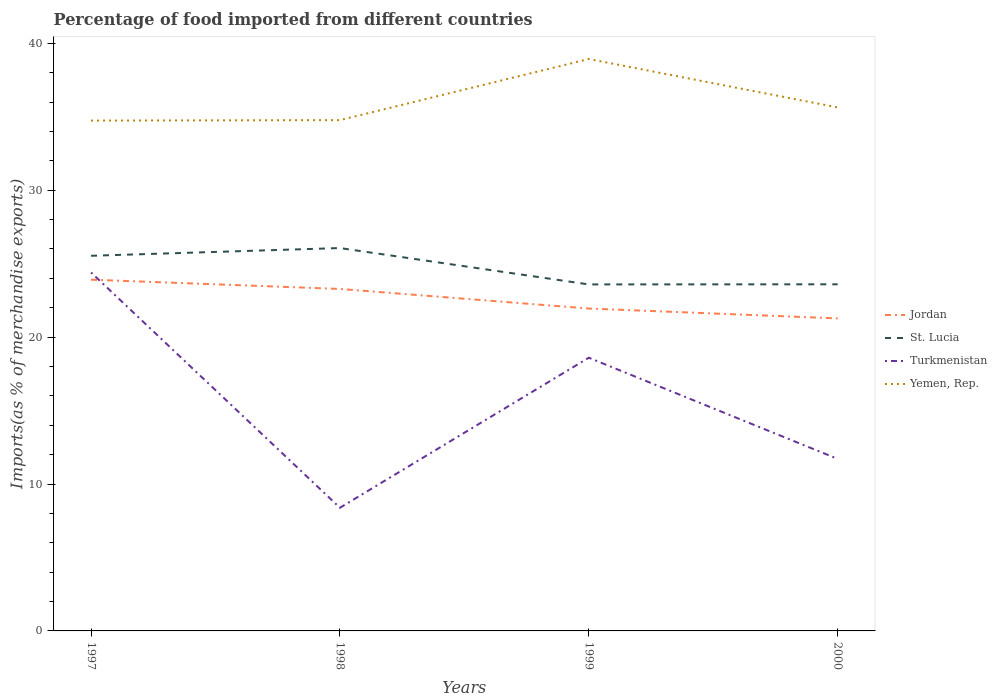Is the number of lines equal to the number of legend labels?
Your answer should be compact. Yes. Across all years, what is the maximum percentage of imports to different countries in Jordan?
Ensure brevity in your answer.  21.28. In which year was the percentage of imports to different countries in Turkmenistan maximum?
Offer a very short reply. 1998. What is the total percentage of imports to different countries in Turkmenistan in the graph?
Your answer should be compact. -10.21. What is the difference between the highest and the second highest percentage of imports to different countries in St. Lucia?
Offer a terse response. 2.48. What is the difference between the highest and the lowest percentage of imports to different countries in Yemen, Rep.?
Ensure brevity in your answer.  1. How many lines are there?
Ensure brevity in your answer.  4. Are the values on the major ticks of Y-axis written in scientific E-notation?
Keep it short and to the point. No. Where does the legend appear in the graph?
Offer a very short reply. Center right. How many legend labels are there?
Offer a terse response. 4. How are the legend labels stacked?
Make the answer very short. Vertical. What is the title of the graph?
Offer a very short reply. Percentage of food imported from different countries. What is the label or title of the X-axis?
Your answer should be very brief. Years. What is the label or title of the Y-axis?
Make the answer very short. Imports(as % of merchandise exports). What is the Imports(as % of merchandise exports) in Jordan in 1997?
Make the answer very short. 23.91. What is the Imports(as % of merchandise exports) of St. Lucia in 1997?
Keep it short and to the point. 25.54. What is the Imports(as % of merchandise exports) of Turkmenistan in 1997?
Your answer should be very brief. 24.4. What is the Imports(as % of merchandise exports) of Yemen, Rep. in 1997?
Your answer should be compact. 34.74. What is the Imports(as % of merchandise exports) of Jordan in 1998?
Provide a succinct answer. 23.28. What is the Imports(as % of merchandise exports) of St. Lucia in 1998?
Make the answer very short. 26.06. What is the Imports(as % of merchandise exports) of Turkmenistan in 1998?
Keep it short and to the point. 8.38. What is the Imports(as % of merchandise exports) of Yemen, Rep. in 1998?
Your answer should be very brief. 34.77. What is the Imports(as % of merchandise exports) of Jordan in 1999?
Your response must be concise. 21.95. What is the Imports(as % of merchandise exports) of St. Lucia in 1999?
Your answer should be very brief. 23.59. What is the Imports(as % of merchandise exports) of Turkmenistan in 1999?
Offer a terse response. 18.6. What is the Imports(as % of merchandise exports) in Yemen, Rep. in 1999?
Make the answer very short. 38.93. What is the Imports(as % of merchandise exports) in Jordan in 2000?
Your answer should be very brief. 21.28. What is the Imports(as % of merchandise exports) of St. Lucia in 2000?
Ensure brevity in your answer.  23.6. What is the Imports(as % of merchandise exports) of Turkmenistan in 2000?
Ensure brevity in your answer.  11.71. What is the Imports(as % of merchandise exports) in Yemen, Rep. in 2000?
Your answer should be compact. 35.64. Across all years, what is the maximum Imports(as % of merchandise exports) in Jordan?
Provide a short and direct response. 23.91. Across all years, what is the maximum Imports(as % of merchandise exports) of St. Lucia?
Offer a very short reply. 26.06. Across all years, what is the maximum Imports(as % of merchandise exports) of Turkmenistan?
Keep it short and to the point. 24.4. Across all years, what is the maximum Imports(as % of merchandise exports) in Yemen, Rep.?
Your answer should be compact. 38.93. Across all years, what is the minimum Imports(as % of merchandise exports) in Jordan?
Your answer should be very brief. 21.28. Across all years, what is the minimum Imports(as % of merchandise exports) of St. Lucia?
Offer a terse response. 23.59. Across all years, what is the minimum Imports(as % of merchandise exports) of Turkmenistan?
Your answer should be compact. 8.38. Across all years, what is the minimum Imports(as % of merchandise exports) of Yemen, Rep.?
Your answer should be very brief. 34.74. What is the total Imports(as % of merchandise exports) of Jordan in the graph?
Offer a very short reply. 90.41. What is the total Imports(as % of merchandise exports) of St. Lucia in the graph?
Give a very brief answer. 98.79. What is the total Imports(as % of merchandise exports) of Turkmenistan in the graph?
Keep it short and to the point. 63.1. What is the total Imports(as % of merchandise exports) in Yemen, Rep. in the graph?
Your response must be concise. 144.08. What is the difference between the Imports(as % of merchandise exports) in Jordan in 1997 and that in 1998?
Your answer should be very brief. 0.63. What is the difference between the Imports(as % of merchandise exports) in St. Lucia in 1997 and that in 1998?
Make the answer very short. -0.53. What is the difference between the Imports(as % of merchandise exports) in Turkmenistan in 1997 and that in 1998?
Make the answer very short. 16.02. What is the difference between the Imports(as % of merchandise exports) of Yemen, Rep. in 1997 and that in 1998?
Your answer should be compact. -0.03. What is the difference between the Imports(as % of merchandise exports) of Jordan in 1997 and that in 1999?
Make the answer very short. 1.96. What is the difference between the Imports(as % of merchandise exports) in St. Lucia in 1997 and that in 1999?
Give a very brief answer. 1.95. What is the difference between the Imports(as % of merchandise exports) in Turkmenistan in 1997 and that in 1999?
Your answer should be compact. 5.81. What is the difference between the Imports(as % of merchandise exports) in Yemen, Rep. in 1997 and that in 1999?
Provide a succinct answer. -4.19. What is the difference between the Imports(as % of merchandise exports) of Jordan in 1997 and that in 2000?
Offer a terse response. 2.64. What is the difference between the Imports(as % of merchandise exports) in St. Lucia in 1997 and that in 2000?
Give a very brief answer. 1.94. What is the difference between the Imports(as % of merchandise exports) of Turkmenistan in 1997 and that in 2000?
Ensure brevity in your answer.  12.69. What is the difference between the Imports(as % of merchandise exports) of Yemen, Rep. in 1997 and that in 2000?
Make the answer very short. -0.9. What is the difference between the Imports(as % of merchandise exports) in Jordan in 1998 and that in 1999?
Your answer should be compact. 1.33. What is the difference between the Imports(as % of merchandise exports) in St. Lucia in 1998 and that in 1999?
Offer a terse response. 2.48. What is the difference between the Imports(as % of merchandise exports) in Turkmenistan in 1998 and that in 1999?
Provide a succinct answer. -10.21. What is the difference between the Imports(as % of merchandise exports) in Yemen, Rep. in 1998 and that in 1999?
Make the answer very short. -4.16. What is the difference between the Imports(as % of merchandise exports) in Jordan in 1998 and that in 2000?
Your answer should be compact. 2. What is the difference between the Imports(as % of merchandise exports) of St. Lucia in 1998 and that in 2000?
Offer a terse response. 2.47. What is the difference between the Imports(as % of merchandise exports) in Turkmenistan in 1998 and that in 2000?
Your answer should be compact. -3.33. What is the difference between the Imports(as % of merchandise exports) in Yemen, Rep. in 1998 and that in 2000?
Provide a succinct answer. -0.86. What is the difference between the Imports(as % of merchandise exports) of Jordan in 1999 and that in 2000?
Offer a terse response. 0.67. What is the difference between the Imports(as % of merchandise exports) of St. Lucia in 1999 and that in 2000?
Your answer should be compact. -0.01. What is the difference between the Imports(as % of merchandise exports) in Turkmenistan in 1999 and that in 2000?
Give a very brief answer. 6.89. What is the difference between the Imports(as % of merchandise exports) in Yemen, Rep. in 1999 and that in 2000?
Make the answer very short. 3.3. What is the difference between the Imports(as % of merchandise exports) of Jordan in 1997 and the Imports(as % of merchandise exports) of St. Lucia in 1998?
Keep it short and to the point. -2.15. What is the difference between the Imports(as % of merchandise exports) of Jordan in 1997 and the Imports(as % of merchandise exports) of Turkmenistan in 1998?
Your answer should be compact. 15.53. What is the difference between the Imports(as % of merchandise exports) in Jordan in 1997 and the Imports(as % of merchandise exports) in Yemen, Rep. in 1998?
Make the answer very short. -10.86. What is the difference between the Imports(as % of merchandise exports) of St. Lucia in 1997 and the Imports(as % of merchandise exports) of Turkmenistan in 1998?
Keep it short and to the point. 17.15. What is the difference between the Imports(as % of merchandise exports) of St. Lucia in 1997 and the Imports(as % of merchandise exports) of Yemen, Rep. in 1998?
Keep it short and to the point. -9.23. What is the difference between the Imports(as % of merchandise exports) of Turkmenistan in 1997 and the Imports(as % of merchandise exports) of Yemen, Rep. in 1998?
Make the answer very short. -10.37. What is the difference between the Imports(as % of merchandise exports) of Jordan in 1997 and the Imports(as % of merchandise exports) of St. Lucia in 1999?
Ensure brevity in your answer.  0.32. What is the difference between the Imports(as % of merchandise exports) of Jordan in 1997 and the Imports(as % of merchandise exports) of Turkmenistan in 1999?
Offer a terse response. 5.31. What is the difference between the Imports(as % of merchandise exports) of Jordan in 1997 and the Imports(as % of merchandise exports) of Yemen, Rep. in 1999?
Provide a short and direct response. -15.02. What is the difference between the Imports(as % of merchandise exports) of St. Lucia in 1997 and the Imports(as % of merchandise exports) of Turkmenistan in 1999?
Provide a short and direct response. 6.94. What is the difference between the Imports(as % of merchandise exports) of St. Lucia in 1997 and the Imports(as % of merchandise exports) of Yemen, Rep. in 1999?
Your answer should be compact. -13.39. What is the difference between the Imports(as % of merchandise exports) of Turkmenistan in 1997 and the Imports(as % of merchandise exports) of Yemen, Rep. in 1999?
Provide a short and direct response. -14.53. What is the difference between the Imports(as % of merchandise exports) of Jordan in 1997 and the Imports(as % of merchandise exports) of St. Lucia in 2000?
Make the answer very short. 0.31. What is the difference between the Imports(as % of merchandise exports) of Jordan in 1997 and the Imports(as % of merchandise exports) of Turkmenistan in 2000?
Offer a very short reply. 12.2. What is the difference between the Imports(as % of merchandise exports) in Jordan in 1997 and the Imports(as % of merchandise exports) in Yemen, Rep. in 2000?
Offer a very short reply. -11.73. What is the difference between the Imports(as % of merchandise exports) in St. Lucia in 1997 and the Imports(as % of merchandise exports) in Turkmenistan in 2000?
Ensure brevity in your answer.  13.83. What is the difference between the Imports(as % of merchandise exports) of St. Lucia in 1997 and the Imports(as % of merchandise exports) of Yemen, Rep. in 2000?
Offer a terse response. -10.1. What is the difference between the Imports(as % of merchandise exports) of Turkmenistan in 1997 and the Imports(as % of merchandise exports) of Yemen, Rep. in 2000?
Provide a short and direct response. -11.23. What is the difference between the Imports(as % of merchandise exports) in Jordan in 1998 and the Imports(as % of merchandise exports) in St. Lucia in 1999?
Offer a terse response. -0.31. What is the difference between the Imports(as % of merchandise exports) in Jordan in 1998 and the Imports(as % of merchandise exports) in Turkmenistan in 1999?
Provide a short and direct response. 4.68. What is the difference between the Imports(as % of merchandise exports) in Jordan in 1998 and the Imports(as % of merchandise exports) in Yemen, Rep. in 1999?
Your answer should be compact. -15.65. What is the difference between the Imports(as % of merchandise exports) of St. Lucia in 1998 and the Imports(as % of merchandise exports) of Turkmenistan in 1999?
Make the answer very short. 7.47. What is the difference between the Imports(as % of merchandise exports) in St. Lucia in 1998 and the Imports(as % of merchandise exports) in Yemen, Rep. in 1999?
Offer a terse response. -12.87. What is the difference between the Imports(as % of merchandise exports) in Turkmenistan in 1998 and the Imports(as % of merchandise exports) in Yemen, Rep. in 1999?
Provide a short and direct response. -30.55. What is the difference between the Imports(as % of merchandise exports) in Jordan in 1998 and the Imports(as % of merchandise exports) in St. Lucia in 2000?
Make the answer very short. -0.32. What is the difference between the Imports(as % of merchandise exports) in Jordan in 1998 and the Imports(as % of merchandise exports) in Turkmenistan in 2000?
Make the answer very short. 11.57. What is the difference between the Imports(as % of merchandise exports) of Jordan in 1998 and the Imports(as % of merchandise exports) of Yemen, Rep. in 2000?
Offer a very short reply. -12.36. What is the difference between the Imports(as % of merchandise exports) of St. Lucia in 1998 and the Imports(as % of merchandise exports) of Turkmenistan in 2000?
Ensure brevity in your answer.  14.35. What is the difference between the Imports(as % of merchandise exports) in St. Lucia in 1998 and the Imports(as % of merchandise exports) in Yemen, Rep. in 2000?
Your answer should be very brief. -9.57. What is the difference between the Imports(as % of merchandise exports) of Turkmenistan in 1998 and the Imports(as % of merchandise exports) of Yemen, Rep. in 2000?
Offer a very short reply. -27.25. What is the difference between the Imports(as % of merchandise exports) in Jordan in 1999 and the Imports(as % of merchandise exports) in St. Lucia in 2000?
Your answer should be very brief. -1.65. What is the difference between the Imports(as % of merchandise exports) in Jordan in 1999 and the Imports(as % of merchandise exports) in Turkmenistan in 2000?
Your response must be concise. 10.24. What is the difference between the Imports(as % of merchandise exports) in Jordan in 1999 and the Imports(as % of merchandise exports) in Yemen, Rep. in 2000?
Provide a succinct answer. -13.69. What is the difference between the Imports(as % of merchandise exports) of St. Lucia in 1999 and the Imports(as % of merchandise exports) of Turkmenistan in 2000?
Keep it short and to the point. 11.88. What is the difference between the Imports(as % of merchandise exports) of St. Lucia in 1999 and the Imports(as % of merchandise exports) of Yemen, Rep. in 2000?
Offer a terse response. -12.05. What is the difference between the Imports(as % of merchandise exports) of Turkmenistan in 1999 and the Imports(as % of merchandise exports) of Yemen, Rep. in 2000?
Ensure brevity in your answer.  -17.04. What is the average Imports(as % of merchandise exports) of Jordan per year?
Offer a very short reply. 22.6. What is the average Imports(as % of merchandise exports) of St. Lucia per year?
Provide a short and direct response. 24.7. What is the average Imports(as % of merchandise exports) of Turkmenistan per year?
Make the answer very short. 15.77. What is the average Imports(as % of merchandise exports) of Yemen, Rep. per year?
Provide a short and direct response. 36.02. In the year 1997, what is the difference between the Imports(as % of merchandise exports) in Jordan and Imports(as % of merchandise exports) in St. Lucia?
Your response must be concise. -1.63. In the year 1997, what is the difference between the Imports(as % of merchandise exports) of Jordan and Imports(as % of merchandise exports) of Turkmenistan?
Make the answer very short. -0.49. In the year 1997, what is the difference between the Imports(as % of merchandise exports) of Jordan and Imports(as % of merchandise exports) of Yemen, Rep.?
Keep it short and to the point. -10.83. In the year 1997, what is the difference between the Imports(as % of merchandise exports) of St. Lucia and Imports(as % of merchandise exports) of Turkmenistan?
Offer a very short reply. 1.13. In the year 1997, what is the difference between the Imports(as % of merchandise exports) of St. Lucia and Imports(as % of merchandise exports) of Yemen, Rep.?
Offer a terse response. -9.2. In the year 1997, what is the difference between the Imports(as % of merchandise exports) in Turkmenistan and Imports(as % of merchandise exports) in Yemen, Rep.?
Your answer should be compact. -10.34. In the year 1998, what is the difference between the Imports(as % of merchandise exports) in Jordan and Imports(as % of merchandise exports) in St. Lucia?
Keep it short and to the point. -2.78. In the year 1998, what is the difference between the Imports(as % of merchandise exports) in Jordan and Imports(as % of merchandise exports) in Turkmenistan?
Ensure brevity in your answer.  14.9. In the year 1998, what is the difference between the Imports(as % of merchandise exports) in Jordan and Imports(as % of merchandise exports) in Yemen, Rep.?
Your answer should be very brief. -11.49. In the year 1998, what is the difference between the Imports(as % of merchandise exports) of St. Lucia and Imports(as % of merchandise exports) of Turkmenistan?
Give a very brief answer. 17.68. In the year 1998, what is the difference between the Imports(as % of merchandise exports) of St. Lucia and Imports(as % of merchandise exports) of Yemen, Rep.?
Provide a succinct answer. -8.71. In the year 1998, what is the difference between the Imports(as % of merchandise exports) in Turkmenistan and Imports(as % of merchandise exports) in Yemen, Rep.?
Ensure brevity in your answer.  -26.39. In the year 1999, what is the difference between the Imports(as % of merchandise exports) of Jordan and Imports(as % of merchandise exports) of St. Lucia?
Your response must be concise. -1.64. In the year 1999, what is the difference between the Imports(as % of merchandise exports) in Jordan and Imports(as % of merchandise exports) in Turkmenistan?
Give a very brief answer. 3.35. In the year 1999, what is the difference between the Imports(as % of merchandise exports) of Jordan and Imports(as % of merchandise exports) of Yemen, Rep.?
Provide a short and direct response. -16.99. In the year 1999, what is the difference between the Imports(as % of merchandise exports) in St. Lucia and Imports(as % of merchandise exports) in Turkmenistan?
Provide a short and direct response. 4.99. In the year 1999, what is the difference between the Imports(as % of merchandise exports) of St. Lucia and Imports(as % of merchandise exports) of Yemen, Rep.?
Offer a very short reply. -15.34. In the year 1999, what is the difference between the Imports(as % of merchandise exports) in Turkmenistan and Imports(as % of merchandise exports) in Yemen, Rep.?
Your answer should be very brief. -20.33. In the year 2000, what is the difference between the Imports(as % of merchandise exports) in Jordan and Imports(as % of merchandise exports) in St. Lucia?
Provide a short and direct response. -2.32. In the year 2000, what is the difference between the Imports(as % of merchandise exports) of Jordan and Imports(as % of merchandise exports) of Turkmenistan?
Your answer should be very brief. 9.56. In the year 2000, what is the difference between the Imports(as % of merchandise exports) in Jordan and Imports(as % of merchandise exports) in Yemen, Rep.?
Offer a very short reply. -14.36. In the year 2000, what is the difference between the Imports(as % of merchandise exports) of St. Lucia and Imports(as % of merchandise exports) of Turkmenistan?
Provide a succinct answer. 11.89. In the year 2000, what is the difference between the Imports(as % of merchandise exports) of St. Lucia and Imports(as % of merchandise exports) of Yemen, Rep.?
Give a very brief answer. -12.04. In the year 2000, what is the difference between the Imports(as % of merchandise exports) in Turkmenistan and Imports(as % of merchandise exports) in Yemen, Rep.?
Your answer should be very brief. -23.93. What is the ratio of the Imports(as % of merchandise exports) in Jordan in 1997 to that in 1998?
Ensure brevity in your answer.  1.03. What is the ratio of the Imports(as % of merchandise exports) in St. Lucia in 1997 to that in 1998?
Ensure brevity in your answer.  0.98. What is the ratio of the Imports(as % of merchandise exports) of Turkmenistan in 1997 to that in 1998?
Give a very brief answer. 2.91. What is the ratio of the Imports(as % of merchandise exports) of Jordan in 1997 to that in 1999?
Keep it short and to the point. 1.09. What is the ratio of the Imports(as % of merchandise exports) of St. Lucia in 1997 to that in 1999?
Offer a very short reply. 1.08. What is the ratio of the Imports(as % of merchandise exports) of Turkmenistan in 1997 to that in 1999?
Give a very brief answer. 1.31. What is the ratio of the Imports(as % of merchandise exports) in Yemen, Rep. in 1997 to that in 1999?
Offer a very short reply. 0.89. What is the ratio of the Imports(as % of merchandise exports) in Jordan in 1997 to that in 2000?
Give a very brief answer. 1.12. What is the ratio of the Imports(as % of merchandise exports) of St. Lucia in 1997 to that in 2000?
Provide a succinct answer. 1.08. What is the ratio of the Imports(as % of merchandise exports) of Turkmenistan in 1997 to that in 2000?
Your answer should be compact. 2.08. What is the ratio of the Imports(as % of merchandise exports) in Yemen, Rep. in 1997 to that in 2000?
Provide a succinct answer. 0.97. What is the ratio of the Imports(as % of merchandise exports) in Jordan in 1998 to that in 1999?
Provide a short and direct response. 1.06. What is the ratio of the Imports(as % of merchandise exports) of St. Lucia in 1998 to that in 1999?
Offer a very short reply. 1.1. What is the ratio of the Imports(as % of merchandise exports) in Turkmenistan in 1998 to that in 1999?
Your answer should be very brief. 0.45. What is the ratio of the Imports(as % of merchandise exports) of Yemen, Rep. in 1998 to that in 1999?
Your answer should be compact. 0.89. What is the ratio of the Imports(as % of merchandise exports) of Jordan in 1998 to that in 2000?
Provide a succinct answer. 1.09. What is the ratio of the Imports(as % of merchandise exports) of St. Lucia in 1998 to that in 2000?
Your response must be concise. 1.1. What is the ratio of the Imports(as % of merchandise exports) in Turkmenistan in 1998 to that in 2000?
Your response must be concise. 0.72. What is the ratio of the Imports(as % of merchandise exports) of Yemen, Rep. in 1998 to that in 2000?
Offer a very short reply. 0.98. What is the ratio of the Imports(as % of merchandise exports) in Jordan in 1999 to that in 2000?
Ensure brevity in your answer.  1.03. What is the ratio of the Imports(as % of merchandise exports) in Turkmenistan in 1999 to that in 2000?
Give a very brief answer. 1.59. What is the ratio of the Imports(as % of merchandise exports) in Yemen, Rep. in 1999 to that in 2000?
Provide a succinct answer. 1.09. What is the difference between the highest and the second highest Imports(as % of merchandise exports) of Jordan?
Give a very brief answer. 0.63. What is the difference between the highest and the second highest Imports(as % of merchandise exports) in St. Lucia?
Ensure brevity in your answer.  0.53. What is the difference between the highest and the second highest Imports(as % of merchandise exports) of Turkmenistan?
Your answer should be compact. 5.81. What is the difference between the highest and the second highest Imports(as % of merchandise exports) of Yemen, Rep.?
Your answer should be very brief. 3.3. What is the difference between the highest and the lowest Imports(as % of merchandise exports) in Jordan?
Your answer should be compact. 2.64. What is the difference between the highest and the lowest Imports(as % of merchandise exports) in St. Lucia?
Keep it short and to the point. 2.48. What is the difference between the highest and the lowest Imports(as % of merchandise exports) in Turkmenistan?
Make the answer very short. 16.02. What is the difference between the highest and the lowest Imports(as % of merchandise exports) in Yemen, Rep.?
Provide a succinct answer. 4.19. 